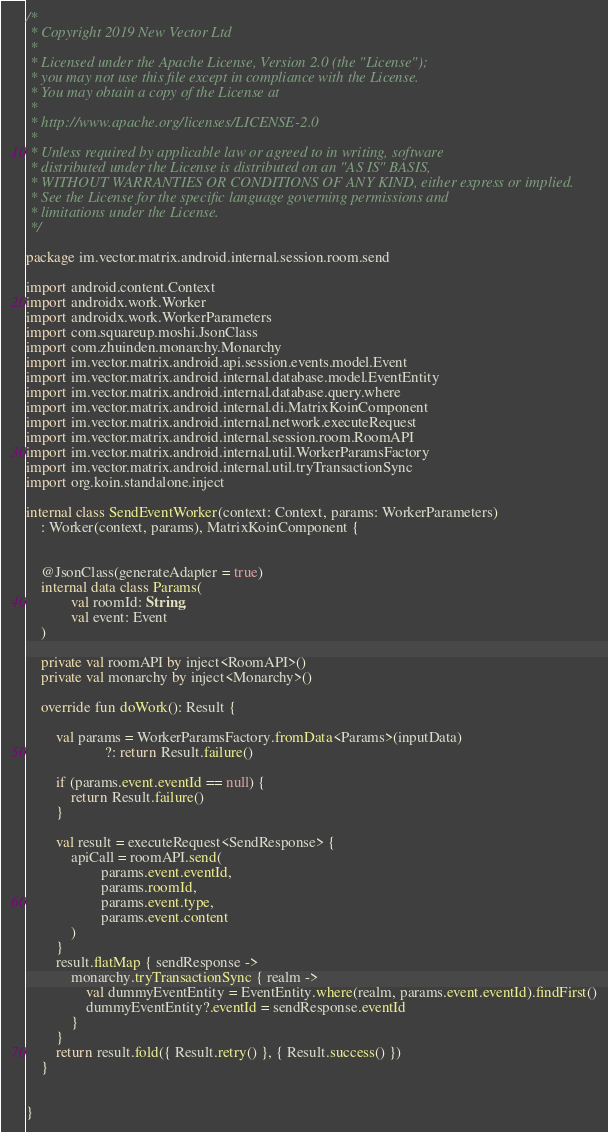Convert code to text. <code><loc_0><loc_0><loc_500><loc_500><_Kotlin_>/*
 * Copyright 2019 New Vector Ltd
 *
 * Licensed under the Apache License, Version 2.0 (the "License");
 * you may not use this file except in compliance with the License.
 * You may obtain a copy of the License at
 *
 * http://www.apache.org/licenses/LICENSE-2.0
 *
 * Unless required by applicable law or agreed to in writing, software
 * distributed under the License is distributed on an "AS IS" BASIS,
 * WITHOUT WARRANTIES OR CONDITIONS OF ANY KIND, either express or implied.
 * See the License for the specific language governing permissions and
 * limitations under the License.
 */

package im.vector.matrix.android.internal.session.room.send

import android.content.Context
import androidx.work.Worker
import androidx.work.WorkerParameters
import com.squareup.moshi.JsonClass
import com.zhuinden.monarchy.Monarchy
import im.vector.matrix.android.api.session.events.model.Event
import im.vector.matrix.android.internal.database.model.EventEntity
import im.vector.matrix.android.internal.database.query.where
import im.vector.matrix.android.internal.di.MatrixKoinComponent
import im.vector.matrix.android.internal.network.executeRequest
import im.vector.matrix.android.internal.session.room.RoomAPI
import im.vector.matrix.android.internal.util.WorkerParamsFactory
import im.vector.matrix.android.internal.util.tryTransactionSync
import org.koin.standalone.inject

internal class SendEventWorker(context: Context, params: WorkerParameters)
    : Worker(context, params), MatrixKoinComponent {


    @JsonClass(generateAdapter = true)
    internal data class Params(
            val roomId: String,
            val event: Event
    )

    private val roomAPI by inject<RoomAPI>()
    private val monarchy by inject<Monarchy>()

    override fun doWork(): Result {

        val params = WorkerParamsFactory.fromData<Params>(inputData)
                     ?: return Result.failure()

        if (params.event.eventId == null) {
            return Result.failure()
        }

        val result = executeRequest<SendResponse> {
            apiCall = roomAPI.send(
                    params.event.eventId,
                    params.roomId,
                    params.event.type,
                    params.event.content
            )
        }
        result.flatMap { sendResponse ->
            monarchy.tryTransactionSync { realm ->
                val dummyEventEntity = EventEntity.where(realm, params.event.eventId).findFirst()
                dummyEventEntity?.eventId = sendResponse.eventId
            }
        }
        return result.fold({ Result.retry() }, { Result.success() })
    }


}
</code> 